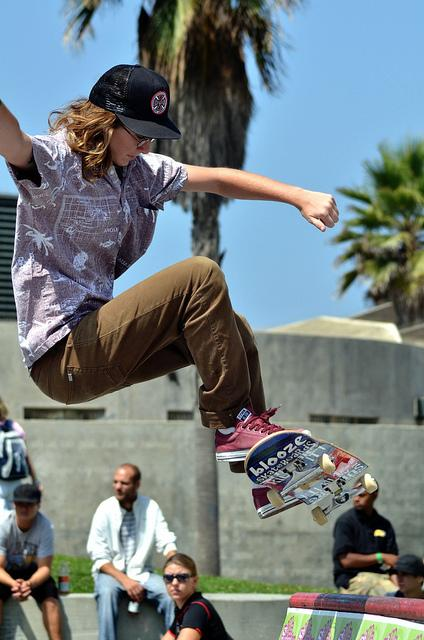In what style park does the skateboarder skate? skate park 